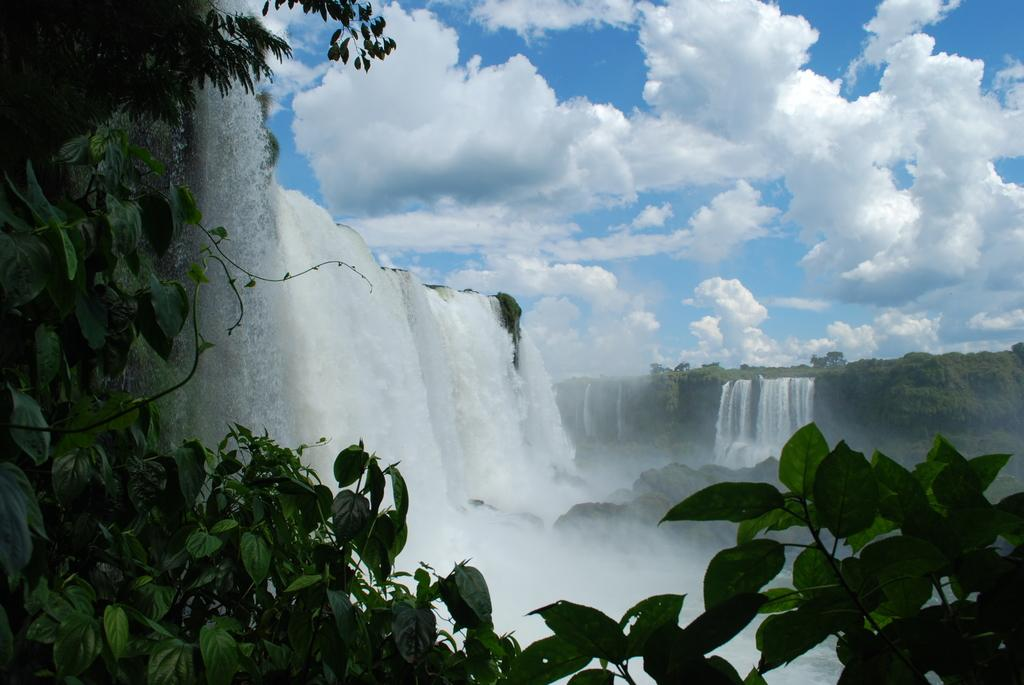What type of vegetation is in the foreground of the image? There are green leaves in the foreground of the image. What natural feature can be seen in the background of the image? There is a waterfall in the background of the image. What else is visible in the background of the image? There are trees in the background of the image. What can be seen in the sky in the image? There are clouds visible in the sky. What tools does the carpenter use to measure the leaves in the image? There is no carpenter present in the image, and the leaves are not being measured. What is the interest rate on the waterfall in the image? There is no financial information or interest rate associated with the waterfall in the image. 